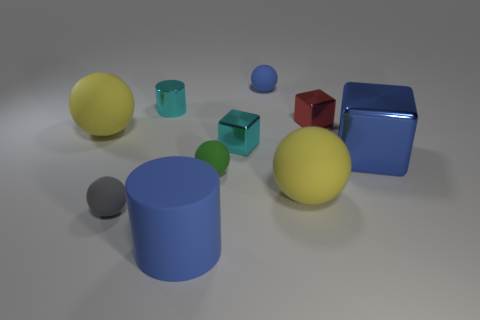Subtract all cyan cubes. How many yellow spheres are left? 2 Subtract all blue rubber balls. How many balls are left? 4 Subtract all yellow spheres. How many spheres are left? 3 Subtract all gray balls. Subtract all green blocks. How many balls are left? 4 Add 8 big yellow things. How many big yellow things are left? 10 Add 1 cubes. How many cubes exist? 4 Subtract 0 red cylinders. How many objects are left? 10 Subtract all cylinders. How many objects are left? 8 Subtract all gray matte spheres. Subtract all balls. How many objects are left? 4 